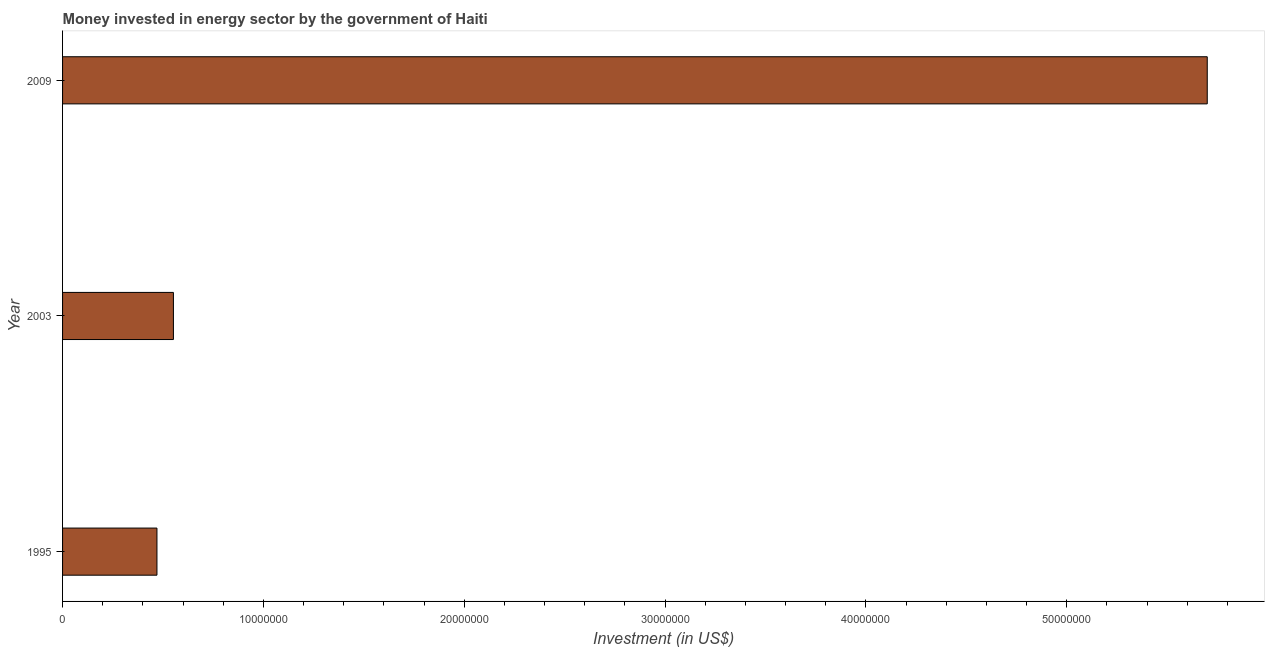What is the title of the graph?
Ensure brevity in your answer.  Money invested in energy sector by the government of Haiti. What is the label or title of the X-axis?
Your answer should be compact. Investment (in US$). What is the investment in energy in 2009?
Your response must be concise. 5.70e+07. Across all years, what is the maximum investment in energy?
Offer a terse response. 5.70e+07. Across all years, what is the minimum investment in energy?
Your response must be concise. 4.70e+06. In which year was the investment in energy maximum?
Your answer should be very brief. 2009. In which year was the investment in energy minimum?
Make the answer very short. 1995. What is the sum of the investment in energy?
Provide a succinct answer. 6.72e+07. What is the difference between the investment in energy in 1995 and 2009?
Make the answer very short. -5.23e+07. What is the average investment in energy per year?
Your response must be concise. 2.24e+07. What is the median investment in energy?
Your answer should be very brief. 5.52e+06. In how many years, is the investment in energy greater than 4000000 US$?
Provide a succinct answer. 3. Do a majority of the years between 2003 and 2009 (inclusive) have investment in energy greater than 54000000 US$?
Make the answer very short. No. What is the ratio of the investment in energy in 1995 to that in 2003?
Offer a very short reply. 0.85. What is the difference between the highest and the second highest investment in energy?
Offer a terse response. 5.15e+07. Is the sum of the investment in energy in 1995 and 2009 greater than the maximum investment in energy across all years?
Ensure brevity in your answer.  Yes. What is the difference between the highest and the lowest investment in energy?
Your answer should be compact. 5.23e+07. In how many years, is the investment in energy greater than the average investment in energy taken over all years?
Give a very brief answer. 1. What is the difference between two consecutive major ticks on the X-axis?
Offer a terse response. 1.00e+07. Are the values on the major ticks of X-axis written in scientific E-notation?
Your response must be concise. No. What is the Investment (in US$) of 1995?
Your response must be concise. 4.70e+06. What is the Investment (in US$) of 2003?
Make the answer very short. 5.52e+06. What is the Investment (in US$) of 2009?
Provide a succinct answer. 5.70e+07. What is the difference between the Investment (in US$) in 1995 and 2003?
Give a very brief answer. -8.20e+05. What is the difference between the Investment (in US$) in 1995 and 2009?
Offer a terse response. -5.23e+07. What is the difference between the Investment (in US$) in 2003 and 2009?
Provide a succinct answer. -5.15e+07. What is the ratio of the Investment (in US$) in 1995 to that in 2003?
Make the answer very short. 0.85. What is the ratio of the Investment (in US$) in 1995 to that in 2009?
Offer a terse response. 0.08. What is the ratio of the Investment (in US$) in 2003 to that in 2009?
Keep it short and to the point. 0.1. 